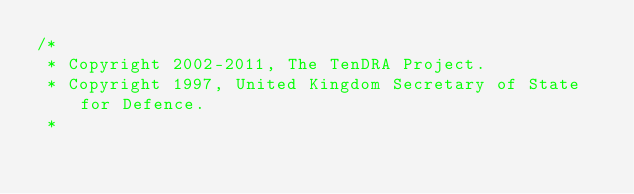<code> <loc_0><loc_0><loc_500><loc_500><_C_>/*
 * Copyright 2002-2011, The TenDRA Project.
 * Copyright 1997, United Kingdom Secretary of State for Defence.
 *</code> 